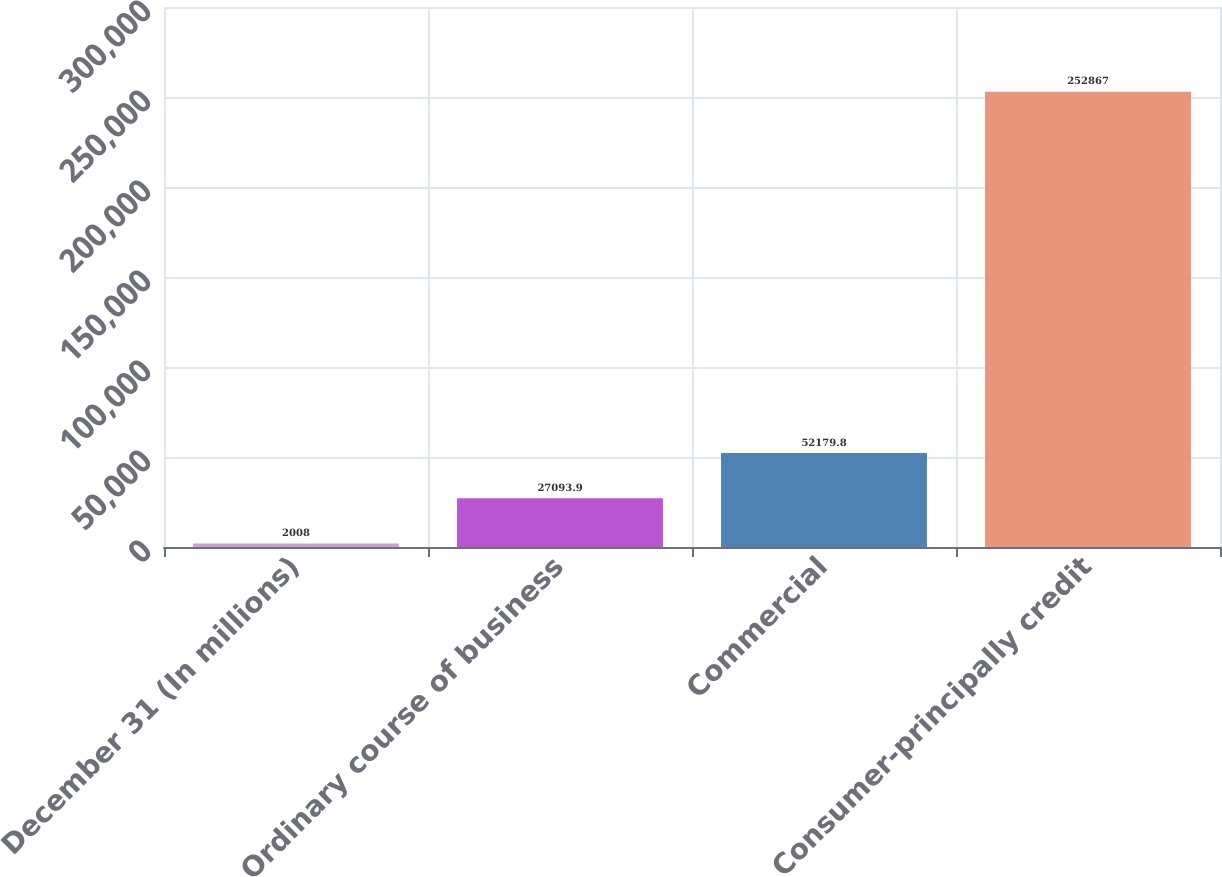Convert chart. <chart><loc_0><loc_0><loc_500><loc_500><bar_chart><fcel>December 31 (In millions)<fcel>Ordinary course of business<fcel>Commercial<fcel>Consumer-principally credit<nl><fcel>2008<fcel>27093.9<fcel>52179.8<fcel>252867<nl></chart> 